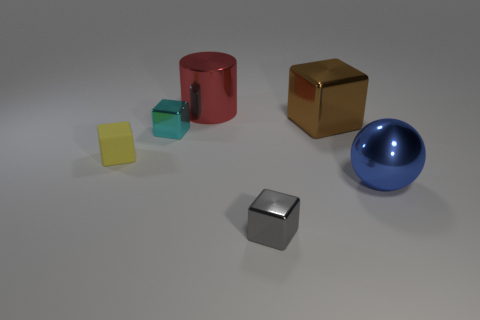The large object in front of the small metal block that is on the left side of the metal cube that is in front of the big ball is made of what material?
Offer a very short reply. Metal. How big is the thing that is both on the right side of the tiny gray shiny thing and behind the small matte thing?
Offer a terse response. Large. Is the shape of the tiny gray shiny object the same as the yellow thing?
Your response must be concise. Yes. What size is the cylinder that is made of the same material as the big blue ball?
Give a very brief answer. Large. What number of other matte objects have the same shape as the brown thing?
Offer a very short reply. 1. What number of cyan shiny balls are there?
Make the answer very short. 0. There is a tiny metallic object in front of the small cyan cube; is it the same shape as the large brown metal thing?
Provide a short and direct response. Yes. There is a blue sphere that is the same size as the cylinder; what is its material?
Offer a terse response. Metal. Is there a tiny cyan object made of the same material as the large cylinder?
Your response must be concise. Yes. Does the gray metal thing have the same shape as the metallic object that is on the left side of the large metal cylinder?
Your response must be concise. Yes. 